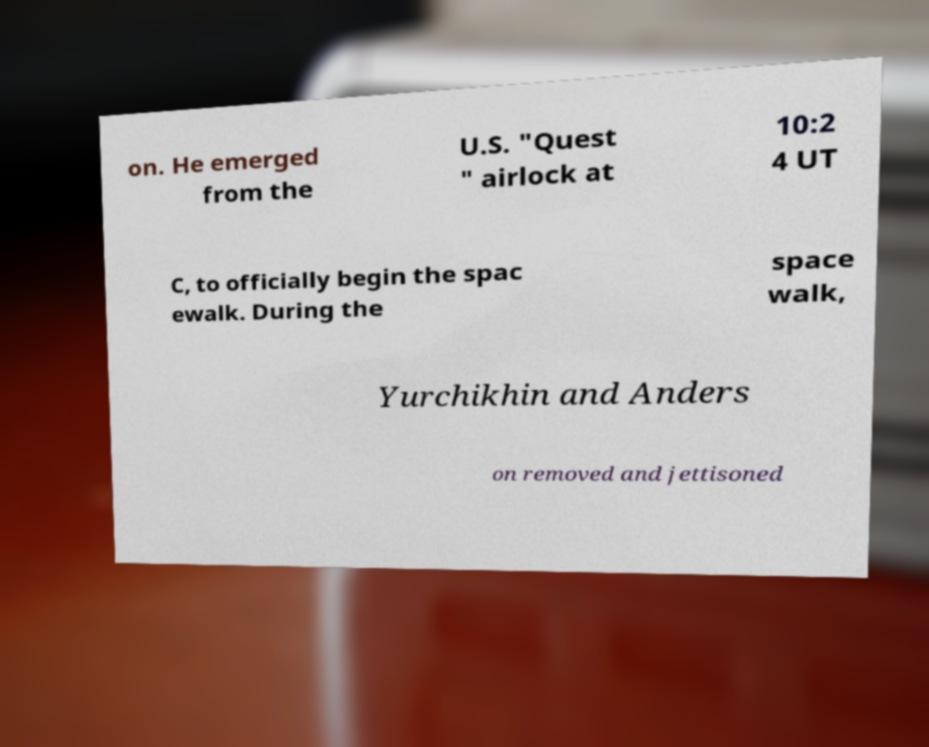I need the written content from this picture converted into text. Can you do that? on. He emerged from the U.S. "Quest " airlock at 10:2 4 UT C, to officially begin the spac ewalk. During the space walk, Yurchikhin and Anders on removed and jettisoned 